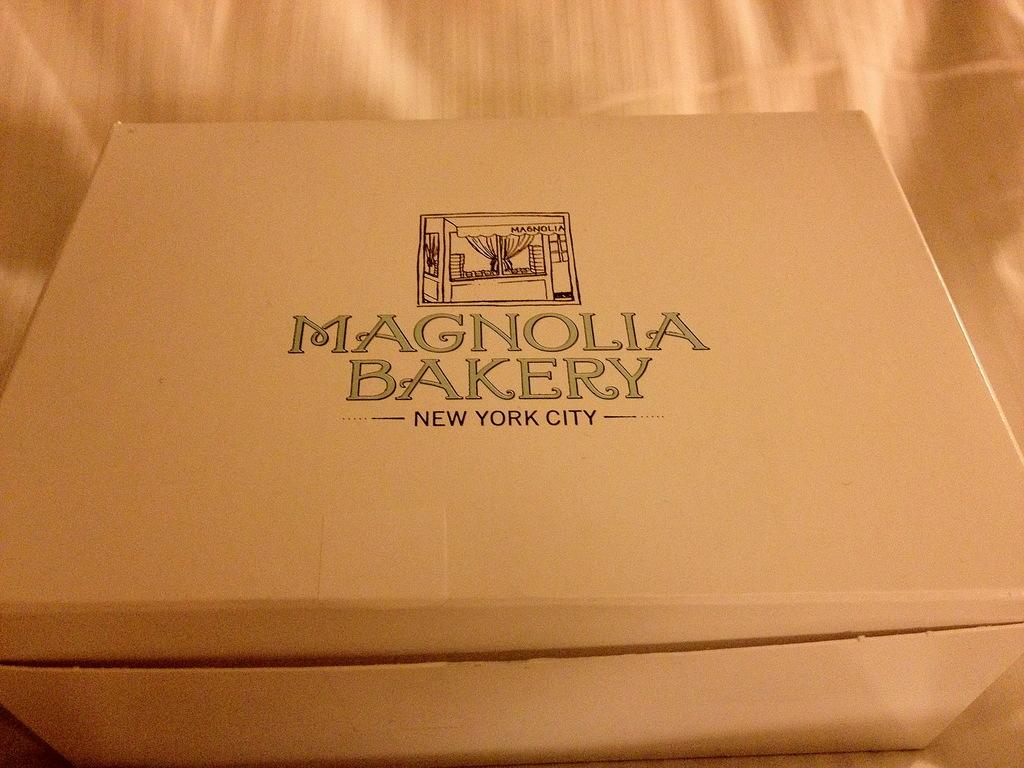<image>
Present a compact description of the photo's key features. Light brown box that is labeled Magnolia Bakery 